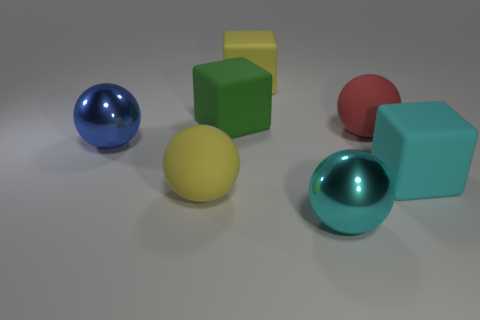What is the shape of the red matte object?
Your answer should be very brief. Sphere. How many balls are green objects or cyan objects?
Offer a terse response. 1. Are there the same number of big yellow matte cubes right of the big cyan shiny thing and large matte things to the left of the green matte cube?
Your answer should be compact. No. There is a yellow matte object in front of the big block that is right of the big cyan shiny ball; how many metallic things are on the left side of it?
Your answer should be compact. 1. Are there more large cyan rubber objects that are on the left side of the cyan metallic object than small green cubes?
Your response must be concise. No. What number of objects are either big matte balls that are left of the green matte cube or big metal objects that are right of the large yellow matte cube?
Keep it short and to the point. 2. The yellow sphere that is made of the same material as the large cyan cube is what size?
Provide a short and direct response. Large. Does the big yellow thing in front of the red object have the same shape as the large cyan rubber object?
Make the answer very short. No. How many blue things are either tiny matte things or large blocks?
Keep it short and to the point. 0. What number of other objects are the same shape as the blue metal thing?
Your answer should be very brief. 3. 